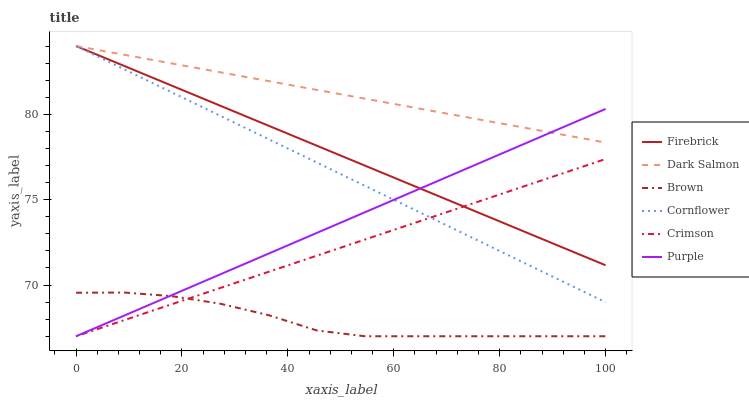Does Brown have the minimum area under the curve?
Answer yes or no. Yes. Does Dark Salmon have the maximum area under the curve?
Answer yes or no. Yes. Does Cornflower have the minimum area under the curve?
Answer yes or no. No. Does Cornflower have the maximum area under the curve?
Answer yes or no. No. Is Purple the smoothest?
Answer yes or no. Yes. Is Brown the roughest?
Answer yes or no. Yes. Is Cornflower the smoothest?
Answer yes or no. No. Is Cornflower the roughest?
Answer yes or no. No. Does Brown have the lowest value?
Answer yes or no. Yes. Does Cornflower have the lowest value?
Answer yes or no. No. Does Dark Salmon have the highest value?
Answer yes or no. Yes. Does Purple have the highest value?
Answer yes or no. No. Is Crimson less than Dark Salmon?
Answer yes or no. Yes. Is Dark Salmon greater than Crimson?
Answer yes or no. Yes. Does Firebrick intersect Crimson?
Answer yes or no. Yes. Is Firebrick less than Crimson?
Answer yes or no. No. Is Firebrick greater than Crimson?
Answer yes or no. No. Does Crimson intersect Dark Salmon?
Answer yes or no. No. 